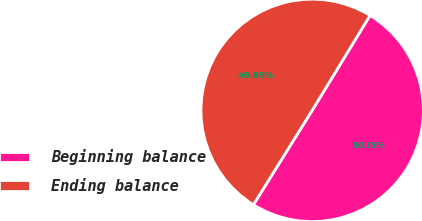Convert chart to OTSL. <chart><loc_0><loc_0><loc_500><loc_500><pie_chart><fcel>Beginning balance<fcel>Ending balance<nl><fcel>50.15%<fcel>49.85%<nl></chart> 